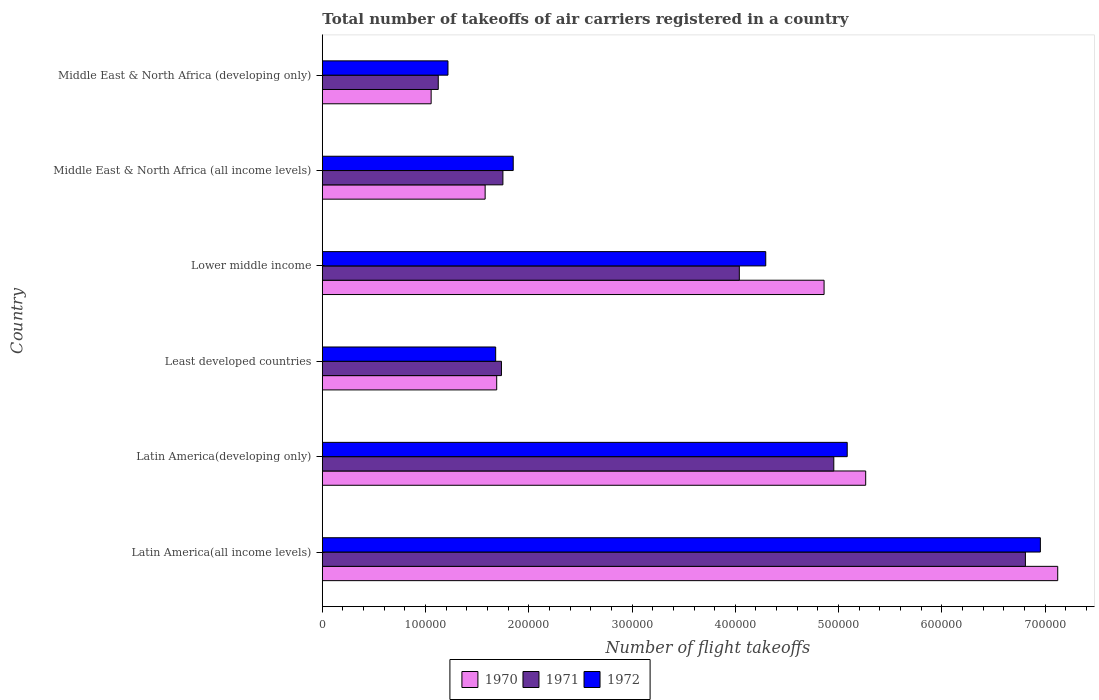How many different coloured bars are there?
Make the answer very short. 3. How many groups of bars are there?
Give a very brief answer. 6. Are the number of bars on each tick of the Y-axis equal?
Your response must be concise. Yes. How many bars are there on the 6th tick from the bottom?
Offer a very short reply. 3. What is the label of the 2nd group of bars from the top?
Offer a terse response. Middle East & North Africa (all income levels). In how many cases, is the number of bars for a given country not equal to the number of legend labels?
Ensure brevity in your answer.  0. What is the total number of flight takeoffs in 1972 in Latin America(developing only)?
Provide a short and direct response. 5.08e+05. Across all countries, what is the maximum total number of flight takeoffs in 1971?
Offer a terse response. 6.81e+05. Across all countries, what is the minimum total number of flight takeoffs in 1971?
Keep it short and to the point. 1.12e+05. In which country was the total number of flight takeoffs in 1970 maximum?
Offer a terse response. Latin America(all income levels). In which country was the total number of flight takeoffs in 1970 minimum?
Make the answer very short. Middle East & North Africa (developing only). What is the total total number of flight takeoffs in 1972 in the graph?
Give a very brief answer. 2.11e+06. What is the difference between the total number of flight takeoffs in 1971 in Lower middle income and that in Middle East & North Africa (developing only)?
Make the answer very short. 2.92e+05. What is the difference between the total number of flight takeoffs in 1972 in Latin America(developing only) and the total number of flight takeoffs in 1970 in Middle East & North Africa (all income levels)?
Your response must be concise. 3.51e+05. What is the average total number of flight takeoffs in 1972 per country?
Keep it short and to the point. 3.51e+05. What is the difference between the total number of flight takeoffs in 1971 and total number of flight takeoffs in 1970 in Middle East & North Africa (all income levels)?
Offer a terse response. 1.72e+04. In how many countries, is the total number of flight takeoffs in 1970 greater than 300000 ?
Your response must be concise. 3. What is the ratio of the total number of flight takeoffs in 1970 in Least developed countries to that in Middle East & North Africa (all income levels)?
Make the answer very short. 1.07. What is the difference between the highest and the second highest total number of flight takeoffs in 1970?
Your answer should be compact. 1.86e+05. What is the difference between the highest and the lowest total number of flight takeoffs in 1971?
Make the answer very short. 5.69e+05. Is the sum of the total number of flight takeoffs in 1972 in Latin America(all income levels) and Lower middle income greater than the maximum total number of flight takeoffs in 1971 across all countries?
Offer a terse response. Yes. What does the 1st bar from the top in Middle East & North Africa (all income levels) represents?
Provide a succinct answer. 1972. What does the 3rd bar from the bottom in Lower middle income represents?
Offer a terse response. 1972. How many bars are there?
Keep it short and to the point. 18. How many countries are there in the graph?
Your answer should be compact. 6. Are the values on the major ticks of X-axis written in scientific E-notation?
Give a very brief answer. No. Does the graph contain any zero values?
Ensure brevity in your answer.  No. Does the graph contain grids?
Your answer should be very brief. No. Where does the legend appear in the graph?
Provide a succinct answer. Bottom center. What is the title of the graph?
Your answer should be compact. Total number of takeoffs of air carriers registered in a country. What is the label or title of the X-axis?
Ensure brevity in your answer.  Number of flight takeoffs. What is the label or title of the Y-axis?
Your answer should be very brief. Country. What is the Number of flight takeoffs in 1970 in Latin America(all income levels)?
Offer a very short reply. 7.12e+05. What is the Number of flight takeoffs of 1971 in Latin America(all income levels)?
Your answer should be compact. 6.81e+05. What is the Number of flight takeoffs of 1972 in Latin America(all income levels)?
Offer a terse response. 6.96e+05. What is the Number of flight takeoffs in 1970 in Latin America(developing only)?
Your answer should be very brief. 5.26e+05. What is the Number of flight takeoffs of 1971 in Latin America(developing only)?
Give a very brief answer. 4.95e+05. What is the Number of flight takeoffs of 1972 in Latin America(developing only)?
Make the answer very short. 5.08e+05. What is the Number of flight takeoffs of 1970 in Least developed countries?
Ensure brevity in your answer.  1.69e+05. What is the Number of flight takeoffs in 1971 in Least developed countries?
Ensure brevity in your answer.  1.74e+05. What is the Number of flight takeoffs in 1972 in Least developed countries?
Ensure brevity in your answer.  1.68e+05. What is the Number of flight takeoffs of 1970 in Lower middle income?
Your answer should be compact. 4.86e+05. What is the Number of flight takeoffs in 1971 in Lower middle income?
Provide a short and direct response. 4.04e+05. What is the Number of flight takeoffs in 1972 in Lower middle income?
Keep it short and to the point. 4.30e+05. What is the Number of flight takeoffs of 1970 in Middle East & North Africa (all income levels)?
Your answer should be compact. 1.58e+05. What is the Number of flight takeoffs of 1971 in Middle East & North Africa (all income levels)?
Offer a very short reply. 1.75e+05. What is the Number of flight takeoffs of 1972 in Middle East & North Africa (all income levels)?
Your response must be concise. 1.85e+05. What is the Number of flight takeoffs of 1970 in Middle East & North Africa (developing only)?
Give a very brief answer. 1.05e+05. What is the Number of flight takeoffs of 1971 in Middle East & North Africa (developing only)?
Offer a terse response. 1.12e+05. What is the Number of flight takeoffs of 1972 in Middle East & North Africa (developing only)?
Your answer should be compact. 1.22e+05. Across all countries, what is the maximum Number of flight takeoffs in 1970?
Ensure brevity in your answer.  7.12e+05. Across all countries, what is the maximum Number of flight takeoffs of 1971?
Ensure brevity in your answer.  6.81e+05. Across all countries, what is the maximum Number of flight takeoffs of 1972?
Offer a terse response. 6.96e+05. Across all countries, what is the minimum Number of flight takeoffs of 1970?
Keep it short and to the point. 1.05e+05. Across all countries, what is the minimum Number of flight takeoffs of 1971?
Your answer should be compact. 1.12e+05. Across all countries, what is the minimum Number of flight takeoffs in 1972?
Your answer should be very brief. 1.22e+05. What is the total Number of flight takeoffs in 1970 in the graph?
Offer a very short reply. 2.16e+06. What is the total Number of flight takeoffs of 1971 in the graph?
Your answer should be compact. 2.04e+06. What is the total Number of flight takeoffs of 1972 in the graph?
Offer a terse response. 2.11e+06. What is the difference between the Number of flight takeoffs of 1970 in Latin America(all income levels) and that in Latin America(developing only)?
Your response must be concise. 1.86e+05. What is the difference between the Number of flight takeoffs in 1971 in Latin America(all income levels) and that in Latin America(developing only)?
Your answer should be compact. 1.86e+05. What is the difference between the Number of flight takeoffs in 1972 in Latin America(all income levels) and that in Latin America(developing only)?
Offer a terse response. 1.87e+05. What is the difference between the Number of flight takeoffs in 1970 in Latin America(all income levels) and that in Least developed countries?
Your answer should be very brief. 5.43e+05. What is the difference between the Number of flight takeoffs of 1971 in Latin America(all income levels) and that in Least developed countries?
Offer a very short reply. 5.08e+05. What is the difference between the Number of flight takeoffs in 1972 in Latin America(all income levels) and that in Least developed countries?
Ensure brevity in your answer.  5.28e+05. What is the difference between the Number of flight takeoffs of 1970 in Latin America(all income levels) and that in Lower middle income?
Keep it short and to the point. 2.26e+05. What is the difference between the Number of flight takeoffs of 1971 in Latin America(all income levels) and that in Lower middle income?
Your response must be concise. 2.77e+05. What is the difference between the Number of flight takeoffs of 1972 in Latin America(all income levels) and that in Lower middle income?
Ensure brevity in your answer.  2.66e+05. What is the difference between the Number of flight takeoffs of 1970 in Latin America(all income levels) and that in Middle East & North Africa (all income levels)?
Your answer should be compact. 5.55e+05. What is the difference between the Number of flight takeoffs in 1971 in Latin America(all income levels) and that in Middle East & North Africa (all income levels)?
Give a very brief answer. 5.06e+05. What is the difference between the Number of flight takeoffs of 1972 in Latin America(all income levels) and that in Middle East & North Africa (all income levels)?
Make the answer very short. 5.11e+05. What is the difference between the Number of flight takeoffs in 1970 in Latin America(all income levels) and that in Middle East & North Africa (developing only)?
Offer a very short reply. 6.07e+05. What is the difference between the Number of flight takeoffs of 1971 in Latin America(all income levels) and that in Middle East & North Africa (developing only)?
Your response must be concise. 5.69e+05. What is the difference between the Number of flight takeoffs of 1972 in Latin America(all income levels) and that in Middle East & North Africa (developing only)?
Your answer should be very brief. 5.74e+05. What is the difference between the Number of flight takeoffs of 1970 in Latin America(developing only) and that in Least developed countries?
Offer a very short reply. 3.57e+05. What is the difference between the Number of flight takeoffs in 1971 in Latin America(developing only) and that in Least developed countries?
Offer a terse response. 3.22e+05. What is the difference between the Number of flight takeoffs of 1972 in Latin America(developing only) and that in Least developed countries?
Make the answer very short. 3.40e+05. What is the difference between the Number of flight takeoffs in 1970 in Latin America(developing only) and that in Lower middle income?
Provide a short and direct response. 4.03e+04. What is the difference between the Number of flight takeoffs of 1971 in Latin America(developing only) and that in Lower middle income?
Provide a succinct answer. 9.15e+04. What is the difference between the Number of flight takeoffs of 1972 in Latin America(developing only) and that in Lower middle income?
Make the answer very short. 7.89e+04. What is the difference between the Number of flight takeoffs in 1970 in Latin America(developing only) and that in Middle East & North Africa (all income levels)?
Offer a terse response. 3.69e+05. What is the difference between the Number of flight takeoffs of 1971 in Latin America(developing only) and that in Middle East & North Africa (all income levels)?
Make the answer very short. 3.20e+05. What is the difference between the Number of flight takeoffs in 1972 in Latin America(developing only) and that in Middle East & North Africa (all income levels)?
Make the answer very short. 3.24e+05. What is the difference between the Number of flight takeoffs in 1970 in Latin America(developing only) and that in Middle East & North Africa (developing only)?
Keep it short and to the point. 4.21e+05. What is the difference between the Number of flight takeoffs in 1971 in Latin America(developing only) and that in Middle East & North Africa (developing only)?
Offer a terse response. 3.83e+05. What is the difference between the Number of flight takeoffs in 1972 in Latin America(developing only) and that in Middle East & North Africa (developing only)?
Your answer should be very brief. 3.87e+05. What is the difference between the Number of flight takeoffs of 1970 in Least developed countries and that in Lower middle income?
Your answer should be very brief. -3.17e+05. What is the difference between the Number of flight takeoffs of 1971 in Least developed countries and that in Lower middle income?
Provide a short and direct response. -2.30e+05. What is the difference between the Number of flight takeoffs of 1972 in Least developed countries and that in Lower middle income?
Your answer should be compact. -2.62e+05. What is the difference between the Number of flight takeoffs in 1970 in Least developed countries and that in Middle East & North Africa (all income levels)?
Your answer should be very brief. 1.12e+04. What is the difference between the Number of flight takeoffs in 1971 in Least developed countries and that in Middle East & North Africa (all income levels)?
Give a very brief answer. -1400. What is the difference between the Number of flight takeoffs of 1972 in Least developed countries and that in Middle East & North Africa (all income levels)?
Offer a very short reply. -1.70e+04. What is the difference between the Number of flight takeoffs of 1970 in Least developed countries and that in Middle East & North Africa (developing only)?
Provide a succinct answer. 6.35e+04. What is the difference between the Number of flight takeoffs in 1971 in Least developed countries and that in Middle East & North Africa (developing only)?
Offer a terse response. 6.12e+04. What is the difference between the Number of flight takeoffs of 1972 in Least developed countries and that in Middle East & North Africa (developing only)?
Provide a short and direct response. 4.62e+04. What is the difference between the Number of flight takeoffs of 1970 in Lower middle income and that in Middle East & North Africa (all income levels)?
Make the answer very short. 3.28e+05. What is the difference between the Number of flight takeoffs in 1971 in Lower middle income and that in Middle East & North Africa (all income levels)?
Provide a succinct answer. 2.29e+05. What is the difference between the Number of flight takeoffs of 1972 in Lower middle income and that in Middle East & North Africa (all income levels)?
Keep it short and to the point. 2.45e+05. What is the difference between the Number of flight takeoffs in 1970 in Lower middle income and that in Middle East & North Africa (developing only)?
Offer a very short reply. 3.81e+05. What is the difference between the Number of flight takeoffs of 1971 in Lower middle income and that in Middle East & North Africa (developing only)?
Your response must be concise. 2.92e+05. What is the difference between the Number of flight takeoffs in 1972 in Lower middle income and that in Middle East & North Africa (developing only)?
Your answer should be compact. 3.08e+05. What is the difference between the Number of flight takeoffs in 1970 in Middle East & North Africa (all income levels) and that in Middle East & North Africa (developing only)?
Your answer should be compact. 5.23e+04. What is the difference between the Number of flight takeoffs in 1971 in Middle East & North Africa (all income levels) and that in Middle East & North Africa (developing only)?
Give a very brief answer. 6.26e+04. What is the difference between the Number of flight takeoffs in 1972 in Middle East & North Africa (all income levels) and that in Middle East & North Africa (developing only)?
Offer a terse response. 6.32e+04. What is the difference between the Number of flight takeoffs of 1970 in Latin America(all income levels) and the Number of flight takeoffs of 1971 in Latin America(developing only)?
Your response must be concise. 2.17e+05. What is the difference between the Number of flight takeoffs in 1970 in Latin America(all income levels) and the Number of flight takeoffs in 1972 in Latin America(developing only)?
Your response must be concise. 2.04e+05. What is the difference between the Number of flight takeoffs in 1971 in Latin America(all income levels) and the Number of flight takeoffs in 1972 in Latin America(developing only)?
Make the answer very short. 1.73e+05. What is the difference between the Number of flight takeoffs of 1970 in Latin America(all income levels) and the Number of flight takeoffs of 1971 in Least developed countries?
Make the answer very short. 5.39e+05. What is the difference between the Number of flight takeoffs in 1970 in Latin America(all income levels) and the Number of flight takeoffs in 1972 in Least developed countries?
Ensure brevity in your answer.  5.44e+05. What is the difference between the Number of flight takeoffs of 1971 in Latin America(all income levels) and the Number of flight takeoffs of 1972 in Least developed countries?
Provide a succinct answer. 5.13e+05. What is the difference between the Number of flight takeoffs in 1970 in Latin America(all income levels) and the Number of flight takeoffs in 1971 in Lower middle income?
Ensure brevity in your answer.  3.08e+05. What is the difference between the Number of flight takeoffs in 1970 in Latin America(all income levels) and the Number of flight takeoffs in 1972 in Lower middle income?
Keep it short and to the point. 2.83e+05. What is the difference between the Number of flight takeoffs of 1971 in Latin America(all income levels) and the Number of flight takeoffs of 1972 in Lower middle income?
Give a very brief answer. 2.52e+05. What is the difference between the Number of flight takeoffs in 1970 in Latin America(all income levels) and the Number of flight takeoffs in 1971 in Middle East & North Africa (all income levels)?
Offer a terse response. 5.37e+05. What is the difference between the Number of flight takeoffs of 1970 in Latin America(all income levels) and the Number of flight takeoffs of 1972 in Middle East & North Africa (all income levels)?
Make the answer very short. 5.27e+05. What is the difference between the Number of flight takeoffs in 1971 in Latin America(all income levels) and the Number of flight takeoffs in 1972 in Middle East & North Africa (all income levels)?
Keep it short and to the point. 4.96e+05. What is the difference between the Number of flight takeoffs of 1970 in Latin America(all income levels) and the Number of flight takeoffs of 1972 in Middle East & North Africa (developing only)?
Offer a terse response. 5.91e+05. What is the difference between the Number of flight takeoffs in 1971 in Latin America(all income levels) and the Number of flight takeoffs in 1972 in Middle East & North Africa (developing only)?
Offer a terse response. 5.59e+05. What is the difference between the Number of flight takeoffs of 1970 in Latin America(developing only) and the Number of flight takeoffs of 1971 in Least developed countries?
Your response must be concise. 3.53e+05. What is the difference between the Number of flight takeoffs in 1970 in Latin America(developing only) and the Number of flight takeoffs in 1972 in Least developed countries?
Your response must be concise. 3.58e+05. What is the difference between the Number of flight takeoffs of 1971 in Latin America(developing only) and the Number of flight takeoffs of 1972 in Least developed countries?
Ensure brevity in your answer.  3.28e+05. What is the difference between the Number of flight takeoffs of 1970 in Latin America(developing only) and the Number of flight takeoffs of 1971 in Lower middle income?
Make the answer very short. 1.22e+05. What is the difference between the Number of flight takeoffs in 1970 in Latin America(developing only) and the Number of flight takeoffs in 1972 in Lower middle income?
Offer a very short reply. 9.68e+04. What is the difference between the Number of flight takeoffs of 1971 in Latin America(developing only) and the Number of flight takeoffs of 1972 in Lower middle income?
Your response must be concise. 6.59e+04. What is the difference between the Number of flight takeoffs of 1970 in Latin America(developing only) and the Number of flight takeoffs of 1971 in Middle East & North Africa (all income levels)?
Ensure brevity in your answer.  3.51e+05. What is the difference between the Number of flight takeoffs in 1970 in Latin America(developing only) and the Number of flight takeoffs in 1972 in Middle East & North Africa (all income levels)?
Your response must be concise. 3.41e+05. What is the difference between the Number of flight takeoffs in 1971 in Latin America(developing only) and the Number of flight takeoffs in 1972 in Middle East & North Africa (all income levels)?
Give a very brief answer. 3.10e+05. What is the difference between the Number of flight takeoffs in 1970 in Latin America(developing only) and the Number of flight takeoffs in 1971 in Middle East & North Africa (developing only)?
Your answer should be very brief. 4.14e+05. What is the difference between the Number of flight takeoffs in 1970 in Latin America(developing only) and the Number of flight takeoffs in 1972 in Middle East & North Africa (developing only)?
Keep it short and to the point. 4.05e+05. What is the difference between the Number of flight takeoffs in 1971 in Latin America(developing only) and the Number of flight takeoffs in 1972 in Middle East & North Africa (developing only)?
Keep it short and to the point. 3.74e+05. What is the difference between the Number of flight takeoffs in 1970 in Least developed countries and the Number of flight takeoffs in 1971 in Lower middle income?
Keep it short and to the point. -2.35e+05. What is the difference between the Number of flight takeoffs of 1970 in Least developed countries and the Number of flight takeoffs of 1972 in Lower middle income?
Provide a succinct answer. -2.61e+05. What is the difference between the Number of flight takeoffs in 1971 in Least developed countries and the Number of flight takeoffs in 1972 in Lower middle income?
Your answer should be very brief. -2.56e+05. What is the difference between the Number of flight takeoffs of 1970 in Least developed countries and the Number of flight takeoffs of 1971 in Middle East & North Africa (all income levels)?
Offer a terse response. -6000. What is the difference between the Number of flight takeoffs in 1970 in Least developed countries and the Number of flight takeoffs in 1972 in Middle East & North Africa (all income levels)?
Provide a succinct answer. -1.60e+04. What is the difference between the Number of flight takeoffs in 1971 in Least developed countries and the Number of flight takeoffs in 1972 in Middle East & North Africa (all income levels)?
Provide a short and direct response. -1.14e+04. What is the difference between the Number of flight takeoffs in 1970 in Least developed countries and the Number of flight takeoffs in 1971 in Middle East & North Africa (developing only)?
Offer a terse response. 5.66e+04. What is the difference between the Number of flight takeoffs in 1970 in Least developed countries and the Number of flight takeoffs in 1972 in Middle East & North Africa (developing only)?
Your answer should be compact. 4.72e+04. What is the difference between the Number of flight takeoffs in 1971 in Least developed countries and the Number of flight takeoffs in 1972 in Middle East & North Africa (developing only)?
Your answer should be compact. 5.18e+04. What is the difference between the Number of flight takeoffs of 1970 in Lower middle income and the Number of flight takeoffs of 1971 in Middle East & North Africa (all income levels)?
Ensure brevity in your answer.  3.11e+05. What is the difference between the Number of flight takeoffs in 1970 in Lower middle income and the Number of flight takeoffs in 1972 in Middle East & North Africa (all income levels)?
Ensure brevity in your answer.  3.01e+05. What is the difference between the Number of flight takeoffs of 1971 in Lower middle income and the Number of flight takeoffs of 1972 in Middle East & North Africa (all income levels)?
Provide a short and direct response. 2.19e+05. What is the difference between the Number of flight takeoffs of 1970 in Lower middle income and the Number of flight takeoffs of 1971 in Middle East & North Africa (developing only)?
Give a very brief answer. 3.74e+05. What is the difference between the Number of flight takeoffs of 1970 in Lower middle income and the Number of flight takeoffs of 1972 in Middle East & North Africa (developing only)?
Provide a short and direct response. 3.64e+05. What is the difference between the Number of flight takeoffs of 1971 in Lower middle income and the Number of flight takeoffs of 1972 in Middle East & North Africa (developing only)?
Provide a succinct answer. 2.82e+05. What is the difference between the Number of flight takeoffs in 1970 in Middle East & North Africa (all income levels) and the Number of flight takeoffs in 1971 in Middle East & North Africa (developing only)?
Keep it short and to the point. 4.54e+04. What is the difference between the Number of flight takeoffs of 1970 in Middle East & North Africa (all income levels) and the Number of flight takeoffs of 1972 in Middle East & North Africa (developing only)?
Ensure brevity in your answer.  3.60e+04. What is the difference between the Number of flight takeoffs in 1971 in Middle East & North Africa (all income levels) and the Number of flight takeoffs in 1972 in Middle East & North Africa (developing only)?
Ensure brevity in your answer.  5.32e+04. What is the average Number of flight takeoffs in 1970 per country?
Give a very brief answer. 3.59e+05. What is the average Number of flight takeoffs of 1971 per country?
Provide a short and direct response. 3.40e+05. What is the average Number of flight takeoffs in 1972 per country?
Your answer should be compact. 3.51e+05. What is the difference between the Number of flight takeoffs of 1970 and Number of flight takeoffs of 1971 in Latin America(all income levels)?
Provide a succinct answer. 3.13e+04. What is the difference between the Number of flight takeoffs of 1970 and Number of flight takeoffs of 1972 in Latin America(all income levels)?
Make the answer very short. 1.68e+04. What is the difference between the Number of flight takeoffs of 1971 and Number of flight takeoffs of 1972 in Latin America(all income levels)?
Offer a terse response. -1.45e+04. What is the difference between the Number of flight takeoffs of 1970 and Number of flight takeoffs of 1971 in Latin America(developing only)?
Provide a short and direct response. 3.09e+04. What is the difference between the Number of flight takeoffs in 1970 and Number of flight takeoffs in 1972 in Latin America(developing only)?
Offer a very short reply. 1.79e+04. What is the difference between the Number of flight takeoffs of 1971 and Number of flight takeoffs of 1972 in Latin America(developing only)?
Offer a terse response. -1.30e+04. What is the difference between the Number of flight takeoffs in 1970 and Number of flight takeoffs in 1971 in Least developed countries?
Your response must be concise. -4600. What is the difference between the Number of flight takeoffs in 1970 and Number of flight takeoffs in 1972 in Least developed countries?
Your answer should be compact. 1000. What is the difference between the Number of flight takeoffs in 1971 and Number of flight takeoffs in 1972 in Least developed countries?
Give a very brief answer. 5600. What is the difference between the Number of flight takeoffs of 1970 and Number of flight takeoffs of 1971 in Lower middle income?
Give a very brief answer. 8.21e+04. What is the difference between the Number of flight takeoffs in 1970 and Number of flight takeoffs in 1972 in Lower middle income?
Your answer should be compact. 5.65e+04. What is the difference between the Number of flight takeoffs of 1971 and Number of flight takeoffs of 1972 in Lower middle income?
Ensure brevity in your answer.  -2.56e+04. What is the difference between the Number of flight takeoffs of 1970 and Number of flight takeoffs of 1971 in Middle East & North Africa (all income levels)?
Your response must be concise. -1.72e+04. What is the difference between the Number of flight takeoffs in 1970 and Number of flight takeoffs in 1972 in Middle East & North Africa (all income levels)?
Make the answer very short. -2.72e+04. What is the difference between the Number of flight takeoffs in 1970 and Number of flight takeoffs in 1971 in Middle East & North Africa (developing only)?
Offer a terse response. -6900. What is the difference between the Number of flight takeoffs of 1970 and Number of flight takeoffs of 1972 in Middle East & North Africa (developing only)?
Ensure brevity in your answer.  -1.63e+04. What is the difference between the Number of flight takeoffs in 1971 and Number of flight takeoffs in 1972 in Middle East & North Africa (developing only)?
Your response must be concise. -9400. What is the ratio of the Number of flight takeoffs in 1970 in Latin America(all income levels) to that in Latin America(developing only)?
Your answer should be compact. 1.35. What is the ratio of the Number of flight takeoffs of 1971 in Latin America(all income levels) to that in Latin America(developing only)?
Provide a short and direct response. 1.37. What is the ratio of the Number of flight takeoffs in 1972 in Latin America(all income levels) to that in Latin America(developing only)?
Your response must be concise. 1.37. What is the ratio of the Number of flight takeoffs of 1970 in Latin America(all income levels) to that in Least developed countries?
Ensure brevity in your answer.  4.22. What is the ratio of the Number of flight takeoffs in 1971 in Latin America(all income levels) to that in Least developed countries?
Ensure brevity in your answer.  3.93. What is the ratio of the Number of flight takeoffs in 1972 in Latin America(all income levels) to that in Least developed countries?
Give a very brief answer. 4.14. What is the ratio of the Number of flight takeoffs of 1970 in Latin America(all income levels) to that in Lower middle income?
Your response must be concise. 1.47. What is the ratio of the Number of flight takeoffs in 1971 in Latin America(all income levels) to that in Lower middle income?
Make the answer very short. 1.69. What is the ratio of the Number of flight takeoffs in 1972 in Latin America(all income levels) to that in Lower middle income?
Provide a succinct answer. 1.62. What is the ratio of the Number of flight takeoffs of 1970 in Latin America(all income levels) to that in Middle East & North Africa (all income levels)?
Make the answer very short. 4.52. What is the ratio of the Number of flight takeoffs of 1971 in Latin America(all income levels) to that in Middle East & North Africa (all income levels)?
Provide a short and direct response. 3.89. What is the ratio of the Number of flight takeoffs of 1972 in Latin America(all income levels) to that in Middle East & North Africa (all income levels)?
Provide a succinct answer. 3.76. What is the ratio of the Number of flight takeoffs in 1970 in Latin America(all income levels) to that in Middle East & North Africa (developing only)?
Offer a terse response. 6.76. What is the ratio of the Number of flight takeoffs of 1971 in Latin America(all income levels) to that in Middle East & North Africa (developing only)?
Offer a terse response. 6.06. What is the ratio of the Number of flight takeoffs in 1972 in Latin America(all income levels) to that in Middle East & North Africa (developing only)?
Ensure brevity in your answer.  5.71. What is the ratio of the Number of flight takeoffs in 1970 in Latin America(developing only) to that in Least developed countries?
Offer a terse response. 3.12. What is the ratio of the Number of flight takeoffs in 1971 in Latin America(developing only) to that in Least developed countries?
Offer a terse response. 2.86. What is the ratio of the Number of flight takeoffs of 1972 in Latin America(developing only) to that in Least developed countries?
Your answer should be very brief. 3.03. What is the ratio of the Number of flight takeoffs in 1970 in Latin America(developing only) to that in Lower middle income?
Provide a succinct answer. 1.08. What is the ratio of the Number of flight takeoffs in 1971 in Latin America(developing only) to that in Lower middle income?
Provide a short and direct response. 1.23. What is the ratio of the Number of flight takeoffs in 1972 in Latin America(developing only) to that in Lower middle income?
Your response must be concise. 1.18. What is the ratio of the Number of flight takeoffs of 1970 in Latin America(developing only) to that in Middle East & North Africa (all income levels)?
Give a very brief answer. 3.34. What is the ratio of the Number of flight takeoffs of 1971 in Latin America(developing only) to that in Middle East & North Africa (all income levels)?
Offer a terse response. 2.83. What is the ratio of the Number of flight takeoffs in 1972 in Latin America(developing only) to that in Middle East & North Africa (all income levels)?
Keep it short and to the point. 2.75. What is the ratio of the Number of flight takeoffs of 1970 in Latin America(developing only) to that in Middle East & North Africa (developing only)?
Your answer should be very brief. 4.99. What is the ratio of the Number of flight takeoffs of 1971 in Latin America(developing only) to that in Middle East & North Africa (developing only)?
Make the answer very short. 4.41. What is the ratio of the Number of flight takeoffs of 1972 in Latin America(developing only) to that in Middle East & North Africa (developing only)?
Give a very brief answer. 4.18. What is the ratio of the Number of flight takeoffs of 1970 in Least developed countries to that in Lower middle income?
Ensure brevity in your answer.  0.35. What is the ratio of the Number of flight takeoffs in 1971 in Least developed countries to that in Lower middle income?
Provide a short and direct response. 0.43. What is the ratio of the Number of flight takeoffs of 1972 in Least developed countries to that in Lower middle income?
Make the answer very short. 0.39. What is the ratio of the Number of flight takeoffs of 1970 in Least developed countries to that in Middle East & North Africa (all income levels)?
Offer a terse response. 1.07. What is the ratio of the Number of flight takeoffs in 1971 in Least developed countries to that in Middle East & North Africa (all income levels)?
Ensure brevity in your answer.  0.99. What is the ratio of the Number of flight takeoffs in 1972 in Least developed countries to that in Middle East & North Africa (all income levels)?
Offer a terse response. 0.91. What is the ratio of the Number of flight takeoffs of 1970 in Least developed countries to that in Middle East & North Africa (developing only)?
Make the answer very short. 1.6. What is the ratio of the Number of flight takeoffs in 1971 in Least developed countries to that in Middle East & North Africa (developing only)?
Your answer should be compact. 1.54. What is the ratio of the Number of flight takeoffs in 1972 in Least developed countries to that in Middle East & North Africa (developing only)?
Your answer should be compact. 1.38. What is the ratio of the Number of flight takeoffs of 1970 in Lower middle income to that in Middle East & North Africa (all income levels)?
Provide a short and direct response. 3.08. What is the ratio of the Number of flight takeoffs of 1971 in Lower middle income to that in Middle East & North Africa (all income levels)?
Offer a terse response. 2.31. What is the ratio of the Number of flight takeoffs of 1972 in Lower middle income to that in Middle East & North Africa (all income levels)?
Give a very brief answer. 2.32. What is the ratio of the Number of flight takeoffs in 1970 in Lower middle income to that in Middle East & North Africa (developing only)?
Offer a terse response. 4.61. What is the ratio of the Number of flight takeoffs in 1971 in Lower middle income to that in Middle East & North Africa (developing only)?
Give a very brief answer. 3.6. What is the ratio of the Number of flight takeoffs in 1972 in Lower middle income to that in Middle East & North Africa (developing only)?
Give a very brief answer. 3.53. What is the ratio of the Number of flight takeoffs of 1970 in Middle East & North Africa (all income levels) to that in Middle East & North Africa (developing only)?
Your response must be concise. 1.5. What is the ratio of the Number of flight takeoffs of 1971 in Middle East & North Africa (all income levels) to that in Middle East & North Africa (developing only)?
Give a very brief answer. 1.56. What is the ratio of the Number of flight takeoffs of 1972 in Middle East & North Africa (all income levels) to that in Middle East & North Africa (developing only)?
Make the answer very short. 1.52. What is the difference between the highest and the second highest Number of flight takeoffs of 1970?
Your answer should be very brief. 1.86e+05. What is the difference between the highest and the second highest Number of flight takeoffs of 1971?
Offer a very short reply. 1.86e+05. What is the difference between the highest and the second highest Number of flight takeoffs of 1972?
Offer a terse response. 1.87e+05. What is the difference between the highest and the lowest Number of flight takeoffs of 1970?
Ensure brevity in your answer.  6.07e+05. What is the difference between the highest and the lowest Number of flight takeoffs of 1971?
Your response must be concise. 5.69e+05. What is the difference between the highest and the lowest Number of flight takeoffs in 1972?
Your answer should be compact. 5.74e+05. 